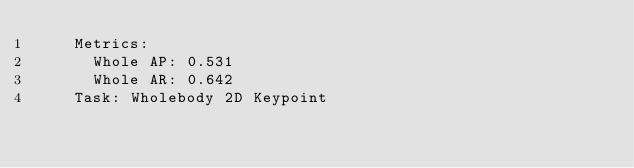<code> <loc_0><loc_0><loc_500><loc_500><_YAML_>    Metrics:
      Whole AP: 0.531
      Whole AR: 0.642
    Task: Wholebody 2D Keypoint</code> 